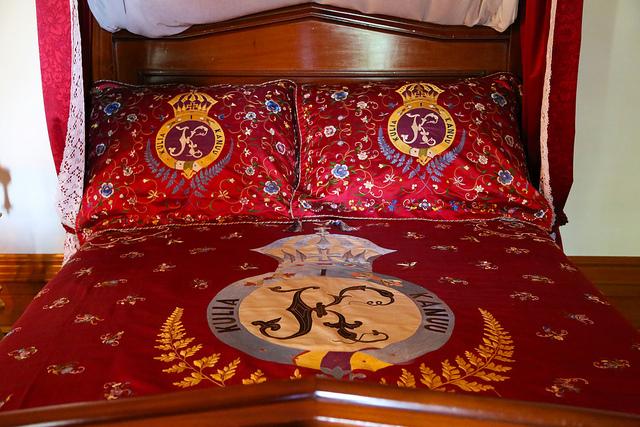How many pillows are there?
Give a very brief answer. 2. What is the picture on the quilt?
Answer briefly. K. What letter is on the sheets?
Be succinct. K. 